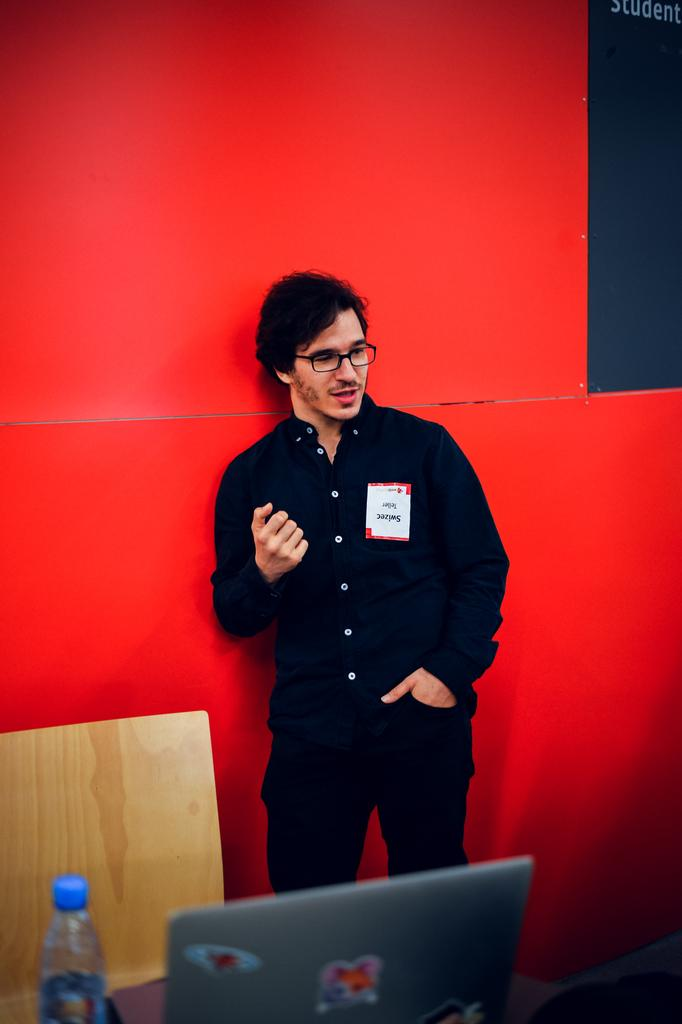What is the main subject of the image? There is a person standing in the image. What objects can be seen near the person? There is a bottle and a laptop in the image. Can you describe the wooden object in the image? There is a wooden object in the image, but its specific characteristics are not mentioned in the facts. What type of stamp can be seen on the person's forehead in the image? There is no stamp present on the person's forehead in the image. What line of work does the person appear to be engaged in based on the image? The image does not provide enough information to determine the person's line of work. 